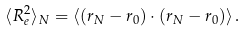<formula> <loc_0><loc_0><loc_500><loc_500>\langle R ^ { 2 } _ { e } \rangle _ { N } = \langle ( { r } _ { N } - { r } _ { 0 } ) \cdot ( { r } _ { N } - { r } _ { 0 } ) \rangle \, .</formula> 